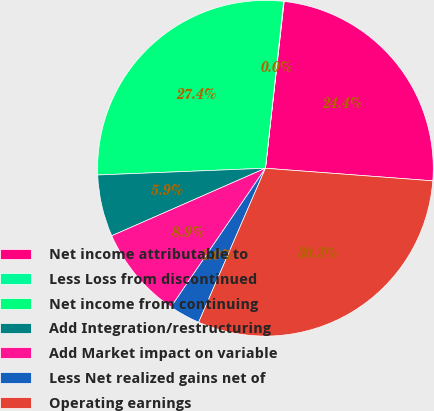<chart> <loc_0><loc_0><loc_500><loc_500><pie_chart><fcel>Net income attributable to<fcel>Less Loss from discontinued<fcel>Net income from continuing<fcel>Add Integration/restructuring<fcel>Add Market impact on variable<fcel>Less Net realized gains net of<fcel>Operating earnings<nl><fcel>24.42%<fcel>0.05%<fcel>27.37%<fcel>5.95%<fcel>8.9%<fcel>3.0%<fcel>30.32%<nl></chart> 